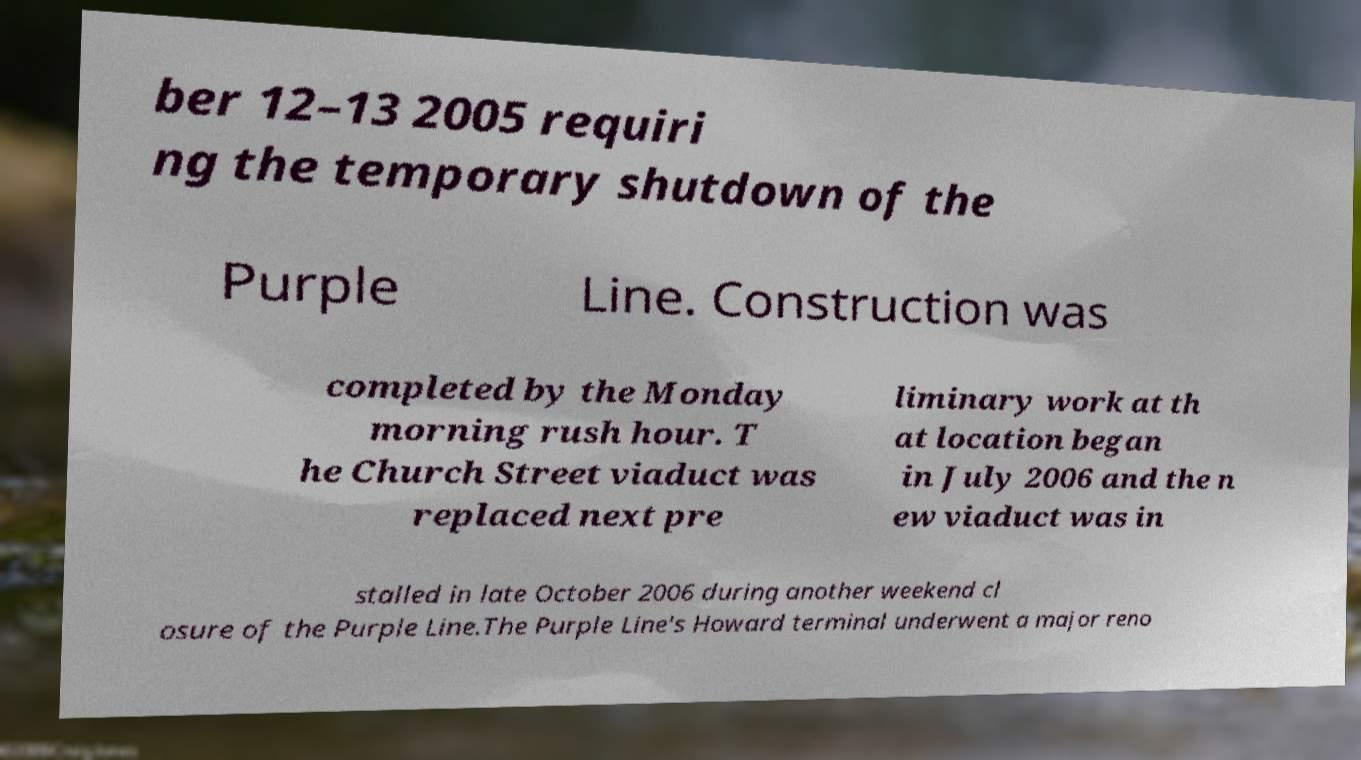For documentation purposes, I need the text within this image transcribed. Could you provide that? ber 12–13 2005 requiri ng the temporary shutdown of the Purple Line. Construction was completed by the Monday morning rush hour. T he Church Street viaduct was replaced next pre liminary work at th at location began in July 2006 and the n ew viaduct was in stalled in late October 2006 during another weekend cl osure of the Purple Line.The Purple Line's Howard terminal underwent a major reno 